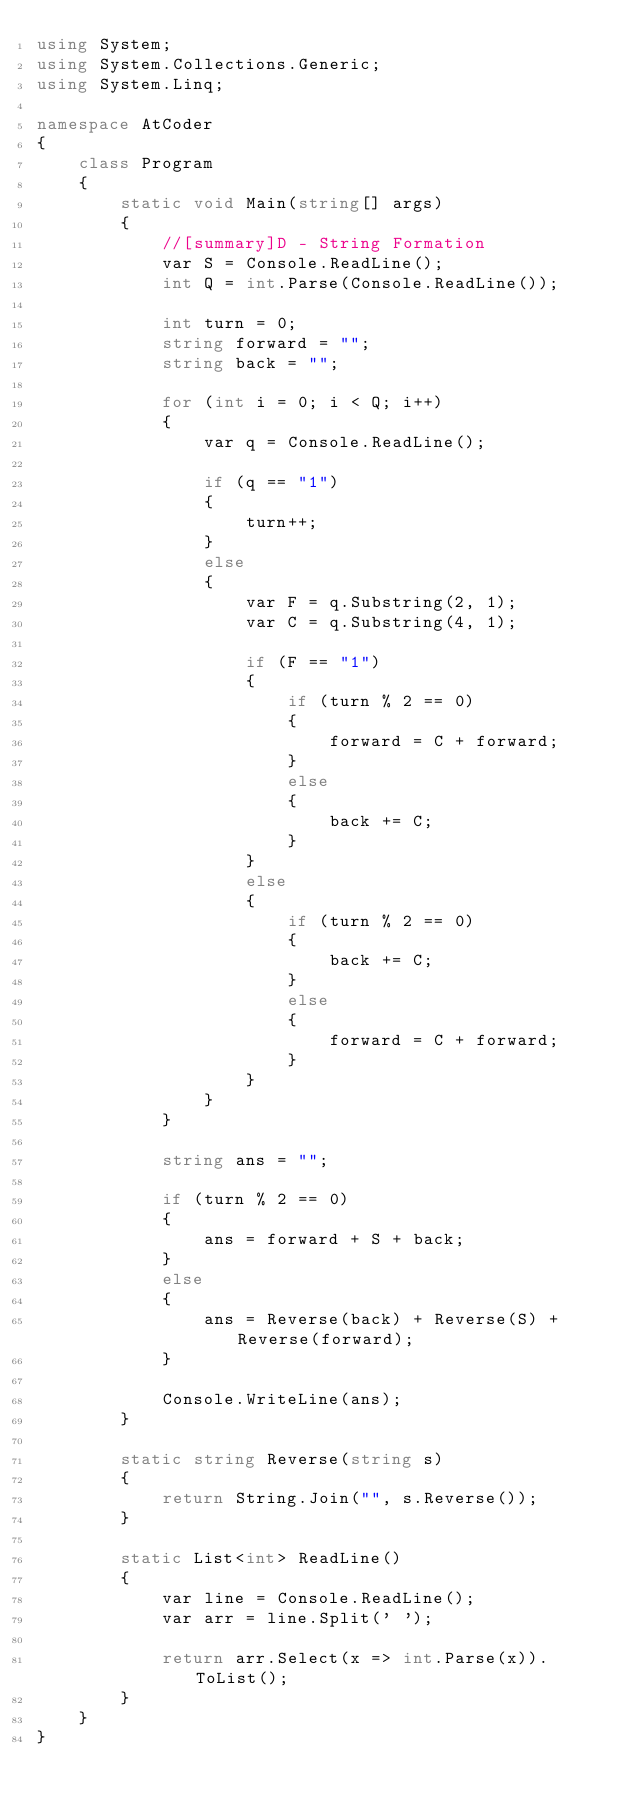<code> <loc_0><loc_0><loc_500><loc_500><_C#_>using System;
using System.Collections.Generic;
using System.Linq;

namespace AtCoder
{
    class Program
    {
        static void Main(string[] args)
        {
            //[summary]D - String Formation
            var S = Console.ReadLine();
            int Q = int.Parse(Console.ReadLine());
            
            int turn = 0;
            string forward = "";
            string back = "";

            for (int i = 0; i < Q; i++)
            {
                var q = Console.ReadLine();

                if (q == "1")
                {
                    turn++;
                }
                else
                {
                    var F = q.Substring(2, 1);
                    var C = q.Substring(4, 1);

                    if (F == "1")
                    {
                        if (turn % 2 == 0)
                        {
                            forward = C + forward;
                        }
                        else
                        {
                            back += C;
                        }
                    }
                    else
                    {
                        if (turn % 2 == 0)
                        {
                            back += C;
                        }
                        else
                        {
                            forward = C + forward;
                        }
                    }
                }
            }

            string ans = "";

            if (turn % 2 == 0)
            {
                ans = forward + S + back;
            }
            else
            {
                ans = Reverse(back) + Reverse(S) + Reverse(forward);
            }

            Console.WriteLine(ans);
        }

        static string Reverse(string s)
        {
            return String.Join("", s.Reverse());
        }

        static List<int> ReadLine()
        {
            var line = Console.ReadLine();
            var arr = line.Split(' ');

            return arr.Select(x => int.Parse(x)).ToList();
        }
    }
}</code> 